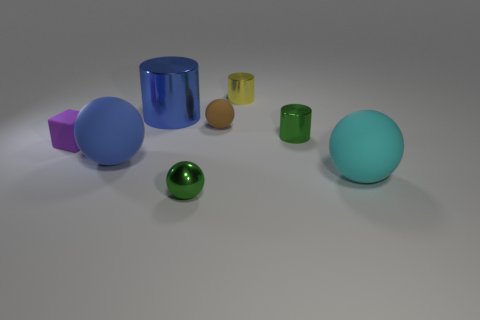Does the tiny block have the same color as the metallic ball?
Your answer should be compact. No. Do the small green metallic object that is behind the small purple cube and the large object to the right of the tiny green shiny ball have the same shape?
Ensure brevity in your answer.  No. There is a brown object that is the same shape as the large blue matte object; what material is it?
Make the answer very short. Rubber. What color is the tiny object that is to the right of the brown object and in front of the brown object?
Make the answer very short. Green. Are there any small purple things that are behind the cylinder left of the metallic object that is in front of the large cyan matte object?
Your answer should be compact. No. How many things are big red matte cylinders or brown rubber things?
Provide a succinct answer. 1. Is the material of the small green sphere the same as the big ball on the left side of the small green shiny cylinder?
Ensure brevity in your answer.  No. Are there any other things that are the same color as the block?
Your response must be concise. No. How many things are either large blue balls that are in front of the small yellow metal object or big spheres that are to the left of the green metal cylinder?
Provide a short and direct response. 1. The thing that is in front of the blue sphere and right of the small yellow cylinder has what shape?
Offer a very short reply. Sphere. 